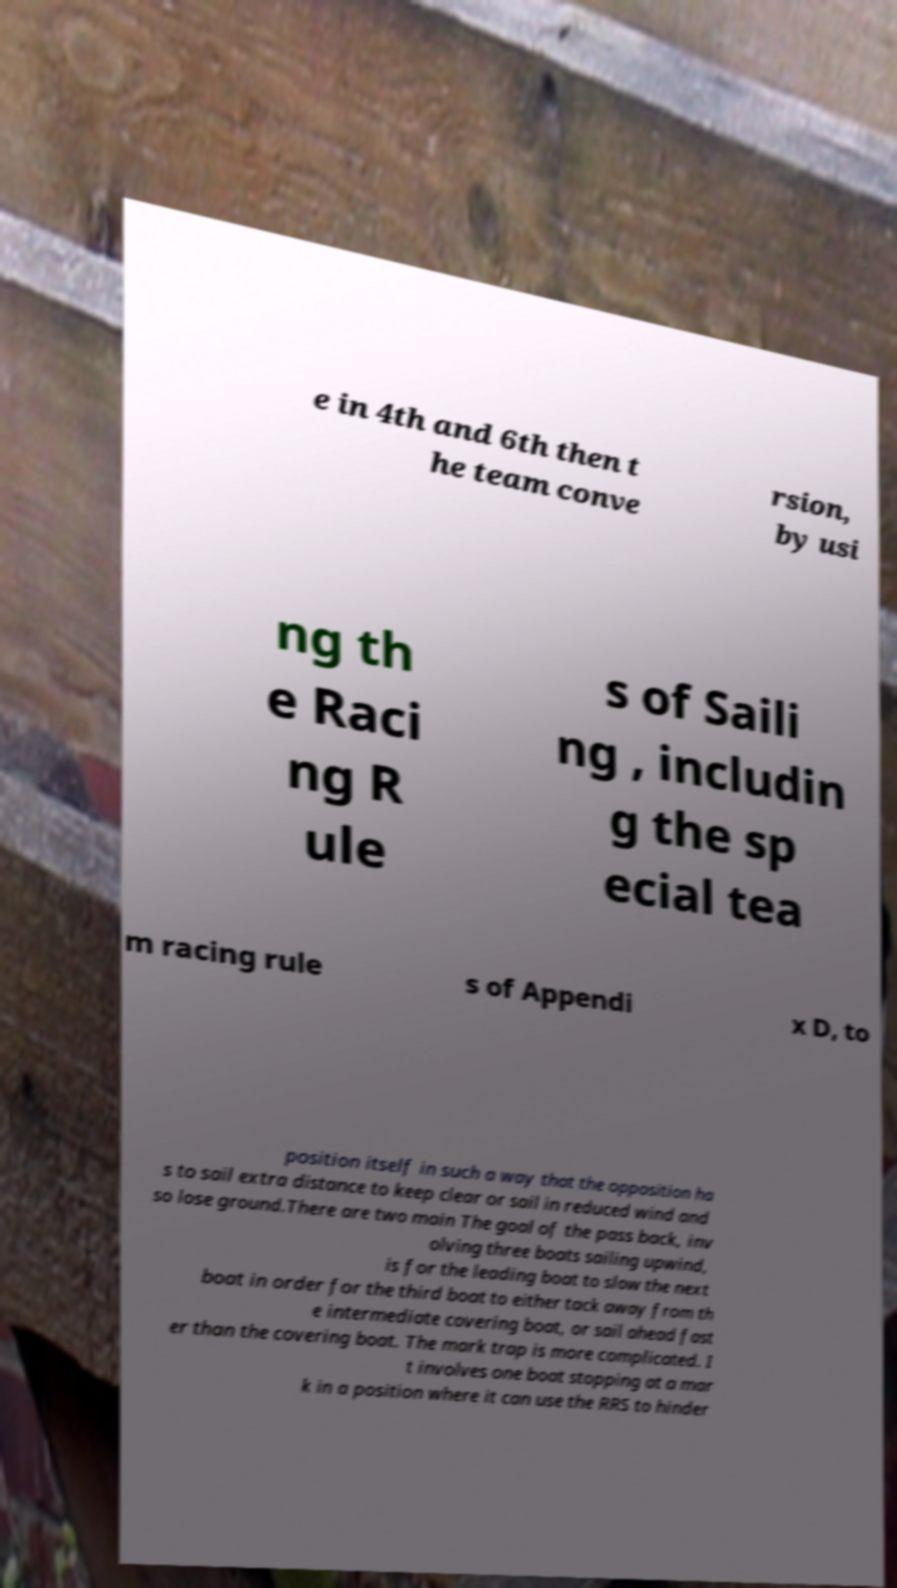There's text embedded in this image that I need extracted. Can you transcribe it verbatim? e in 4th and 6th then t he team conve rsion, by usi ng th e Raci ng R ule s of Saili ng , includin g the sp ecial tea m racing rule s of Appendi x D, to position itself in such a way that the opposition ha s to sail extra distance to keep clear or sail in reduced wind and so lose ground.There are two main The goal of the pass back, inv olving three boats sailing upwind, is for the leading boat to slow the next boat in order for the third boat to either tack away from th e intermediate covering boat, or sail ahead fast er than the covering boat. The mark trap is more complicated. I t involves one boat stopping at a mar k in a position where it can use the RRS to hinder 